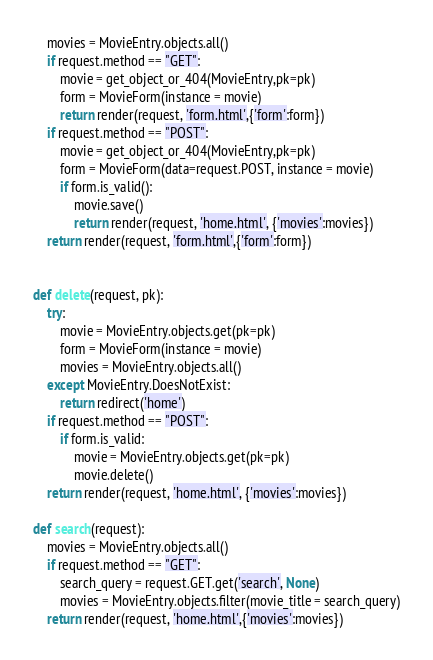Convert code to text. <code><loc_0><loc_0><loc_500><loc_500><_Python_>    movies = MovieEntry.objects.all()
    if request.method == "GET":
        movie = get_object_or_404(MovieEntry,pk=pk)
        form = MovieForm(instance = movie)
        return render(request, 'form.html',{'form':form})
    if request.method == "POST":
        movie = get_object_or_404(MovieEntry,pk=pk)
        form = MovieForm(data=request.POST, instance = movie)
        if form.is_valid():
            movie.save()
            return render(request, 'home.html', {'movies':movies})
    return render(request, 'form.html',{'form':form})


def delete(request, pk):
    try:
        movie = MovieEntry.objects.get(pk=pk)
        form = MovieForm(instance = movie)
        movies = MovieEntry.objects.all()
    except MovieEntry.DoesNotExist:
        return redirect('home')
    if request.method == "POST":
        if form.is_valid:
            movie = MovieEntry.objects.get(pk=pk)
            movie.delete()
    return render(request, 'home.html', {'movies':movies})

def search(request):
    movies = MovieEntry.objects.all()
    if request.method == "GET":
        search_query = request.GET.get('search', None)
        movies = MovieEntry.objects.filter(movie_title = search_query)
    return render(request, 'home.html',{'movies':movies})</code> 